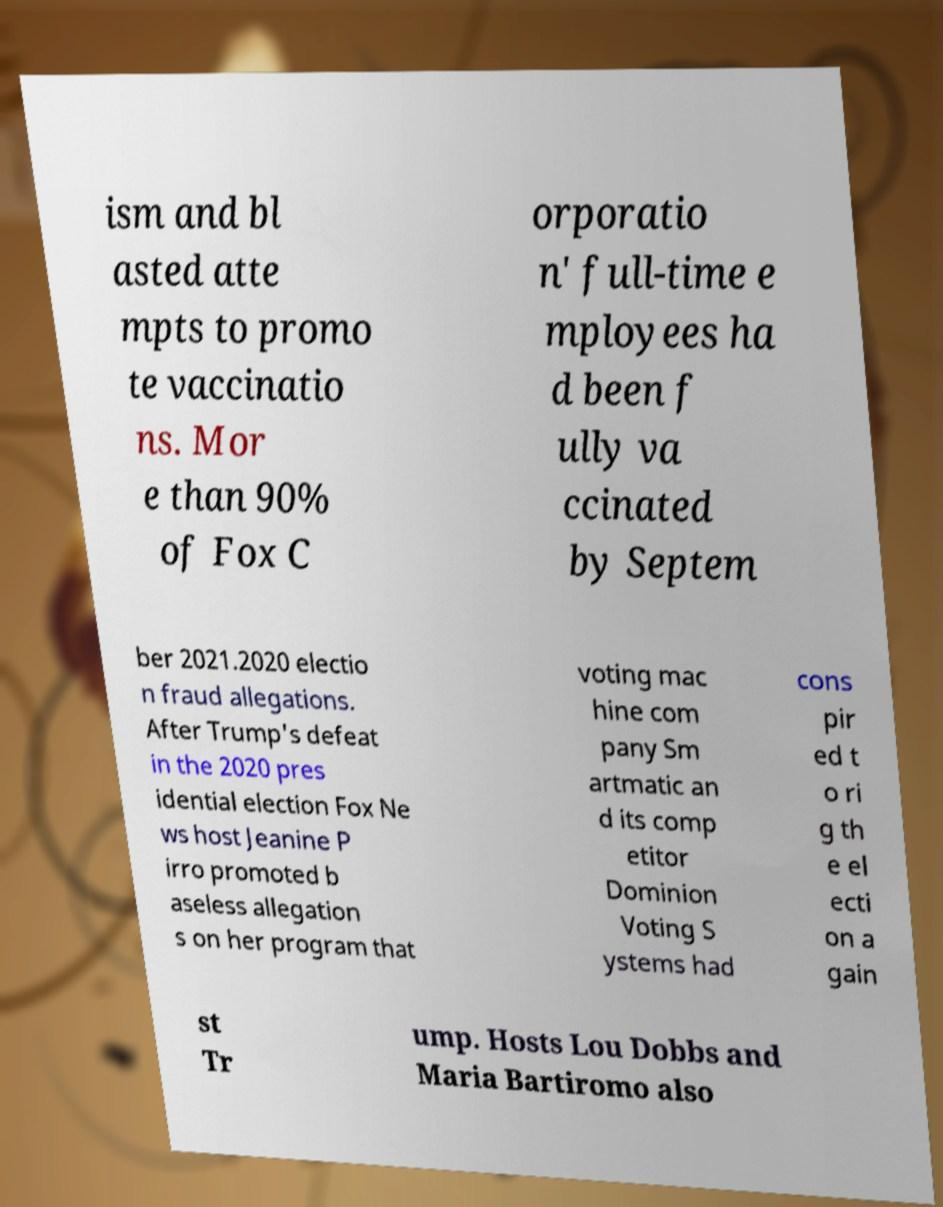Please read and relay the text visible in this image. What does it say? ism and bl asted atte mpts to promo te vaccinatio ns. Mor e than 90% of Fox C orporatio n' full-time e mployees ha d been f ully va ccinated by Septem ber 2021.2020 electio n fraud allegations. After Trump's defeat in the 2020 pres idential election Fox Ne ws host Jeanine P irro promoted b aseless allegation s on her program that voting mac hine com pany Sm artmatic an d its comp etitor Dominion Voting S ystems had cons pir ed t o ri g th e el ecti on a gain st Tr ump. Hosts Lou Dobbs and Maria Bartiromo also 